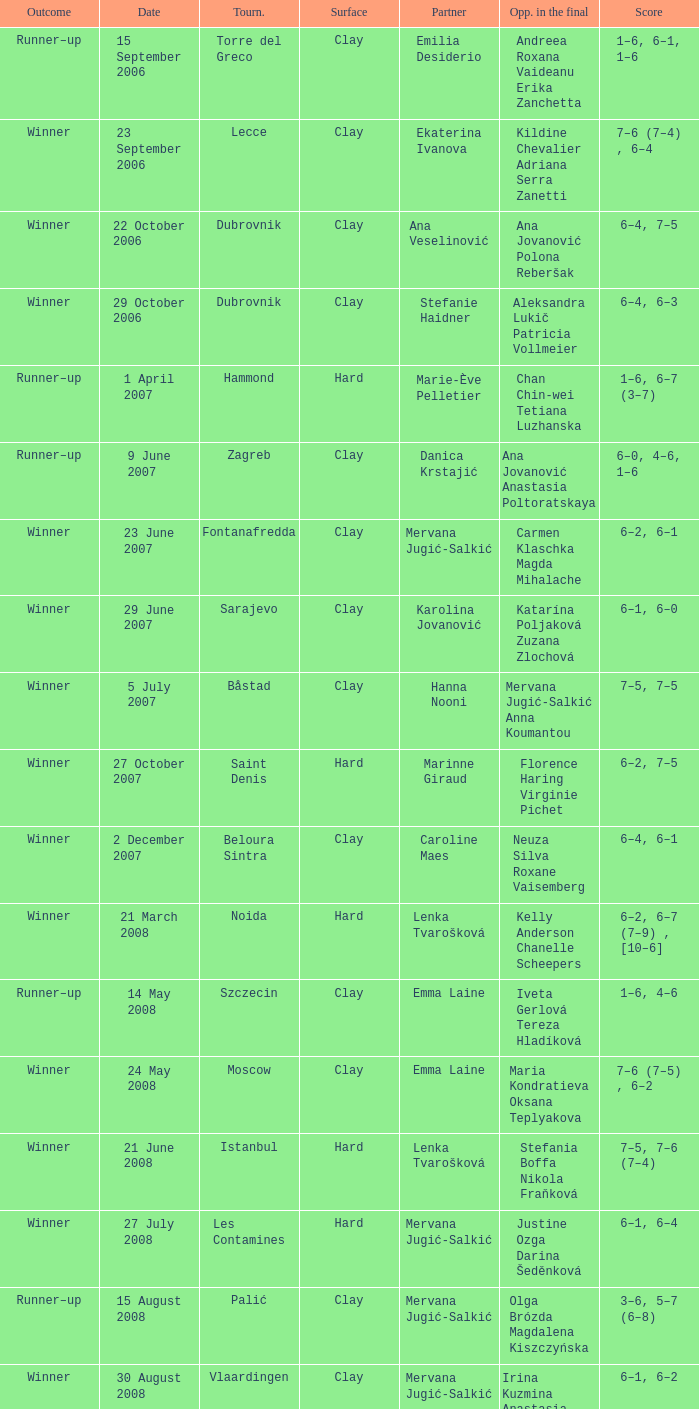Who were the opponents in the final at Noida? Kelly Anderson Chanelle Scheepers. Help me parse the entirety of this table. {'header': ['Outcome', 'Date', 'Tourn.', 'Surface', 'Partner', 'Opp. in the final', 'Score'], 'rows': [['Runner–up', '15 September 2006', 'Torre del Greco', 'Clay', 'Emilia Desiderio', 'Andreea Roxana Vaideanu Erika Zanchetta', '1–6, 6–1, 1–6'], ['Winner', '23 September 2006', 'Lecce', 'Clay', 'Ekaterina Ivanova', 'Kildine Chevalier Adriana Serra Zanetti', '7–6 (7–4) , 6–4'], ['Winner', '22 October 2006', 'Dubrovnik', 'Clay', 'Ana Veselinović', 'Ana Jovanović Polona Reberšak', '6–4, 7–5'], ['Winner', '29 October 2006', 'Dubrovnik', 'Clay', 'Stefanie Haidner', 'Aleksandra Lukič Patricia Vollmeier', '6–4, 6–3'], ['Runner–up', '1 April 2007', 'Hammond', 'Hard', 'Marie-Ève Pelletier', 'Chan Chin-wei Tetiana Luzhanska', '1–6, 6–7 (3–7)'], ['Runner–up', '9 June 2007', 'Zagreb', 'Clay', 'Danica Krstajić', 'Ana Jovanović Anastasia Poltoratskaya', '6–0, 4–6, 1–6'], ['Winner', '23 June 2007', 'Fontanafredda', 'Clay', 'Mervana Jugić-Salkić', 'Carmen Klaschka Magda Mihalache', '6–2, 6–1'], ['Winner', '29 June 2007', 'Sarajevo', 'Clay', 'Karolina Jovanović', 'Katarína Poljaková Zuzana Zlochová', '6–1, 6–0'], ['Winner', '5 July 2007', 'Båstad', 'Clay', 'Hanna Nooni', 'Mervana Jugić-Salkić Anna Koumantou', '7–5, 7–5'], ['Winner', '27 October 2007', 'Saint Denis', 'Hard', 'Marinne Giraud', 'Florence Haring Virginie Pichet', '6–2, 7–5'], ['Winner', '2 December 2007', 'Beloura Sintra', 'Clay', 'Caroline Maes', 'Neuza Silva Roxane Vaisemberg', '6–4, 6–1'], ['Winner', '21 March 2008', 'Noida', 'Hard', 'Lenka Tvarošková', 'Kelly Anderson Chanelle Scheepers', '6–2, 6–7 (7–9) , [10–6]'], ['Runner–up', '14 May 2008', 'Szczecin', 'Clay', 'Emma Laine', 'Iveta Gerlová Tereza Hladíková', '1–6, 4–6'], ['Winner', '24 May 2008', 'Moscow', 'Clay', 'Emma Laine', 'Maria Kondratieva Oksana Teplyakova', '7–6 (7–5) , 6–2'], ['Winner', '21 June 2008', 'Istanbul', 'Hard', 'Lenka Tvarošková', 'Stefania Boffa Nikola Fraňková', '7–5, 7–6 (7–4)'], ['Winner', '27 July 2008', 'Les Contamines', 'Hard', 'Mervana Jugić-Salkić', 'Justine Ozga Darina Šeděnková', '6–1, 6–4'], ['Runner–up', '15 August 2008', 'Palić', 'Clay', 'Mervana Jugić-Salkić', 'Olga Brózda Magdalena Kiszczyńska', '3–6, 5–7 (6–8)'], ['Winner', '30 August 2008', 'Vlaardingen', 'Clay', 'Mervana Jugić-Salkić', 'Irina Kuzmina Anastasia Poltoratskaya', '6–1, 6–2'], ['Winner', '22 November 2008', 'Phoenix', 'Hard', 'Lenka Tvarošková', 'Kelly Anderson Natalie Grandin', '6–4, 3–6, [10–4]'], ['Winner', '12 April 2009', 'Šibenik', 'Clay', 'Nataša Zorić', 'Tina Obrez Mika Urbančič', '6–0, 6–3'], ['Winner', '17 July 2009', 'Rome', 'Clay', 'María Irigoyen', 'Elisa Balsamo Stefania Chieppa', '7–5, 6–2'], ['Winner', '5 September 2009', 'Brčko', 'Clay', 'Ana Jovanović', 'Patricia Chirea Petra Pajalič', '6–4, 6–1'], ['Runner–up', '13 September 2009', 'Denain', 'Clay', 'Magdalena Kiszchzynska', 'Elena Chalova Ksenia Lykina', '4–6, 3–6'], ['Runner–up', '10 October 2009', 'Podgorica', 'Clay', 'Karolina Jovanović', 'Nicole Clerico Karolina Kosińska', '7–6 (7–4) , 4–6, [4–10]'], ['Runner–up', '25 April 2010', 'Dothan', 'Clay', 'María Irigoyen', 'Alina Jidkova Anastasia Yakimova', '4–6, 2–6'], ['Winner', '12 June 2010', 'Budapest', 'Clay', 'Lenka Wienerová', 'Anna Livadaru Florencia Molinero', '6–4, 6–1'], ['Winner', '2 July 2010', 'Toruń', 'Clay', 'Marija Mirkovic', 'Katarzyna Piter Barbara Sobaszkiewicz', '4–6, 6–2, [10–5]'], ['Winner', '10 July 2010', 'Aschaffenburg', 'Clay', 'Erika Sema', 'Elena Bogdan Andrea Koch Benvenuto', '7–6 (7–4) , 2–6, [10–8]'], ['Runner–up', '6 August 2010', 'Moscow', 'Clay', 'Marija Mirkovic', 'Nadejda Guskova Valeria Solovyeva', '6–7 (5–7) , 3–6'], ['Runner–up', '15 January 2011', 'Glasgow', 'Hard (i)', 'Jasmina Tinjić', 'Ulrikke Eikeri Isabella Shinikova', '4–6, 4–6'], ['Winner', '12 February 2011', 'Antalya', 'Clay', 'Maria Shamayko', 'Sultan Gönen Anna Karavayeva', '6–4, 6–4'], ['Runner–up', '29 April 2011', 'Minsk', 'Hard (i)', 'Nicole Rottmann', 'Lyudmyla Kichenok Nadiya Kichenok', '1–6, 2–6'], ['Winner', '18 June 2011', 'Istanbul', 'Hard', 'Marta Domachowska', 'Daniella Dominikovic Melis Sezer', '6–4, 6–2'], ['Winners', '10 September 2011', 'Saransk', 'Clay', 'Mihaela Buzărnescu', 'Eva Hrdinová Veronika Kapshay', '6–3, 6–1'], ['Runner–up', '19-Mar-2012', 'Antalya', 'Clay', 'Claudia Giovine', 'Evelyn Mayr (ITA) Julia Mayr', '2-6,3-6'], ['Winner', '23-Apr-2012', 'San Severo', 'Clay', 'Anastasia Grymalska', 'Chiara Mendo Giulia Sussarello', '6-2 6-4'], ['Winners', '26 May 2012', 'Timișoara , Romania', 'Clay', 'Andreea Mitu', 'Lina Gjorcheska Dalia Zafirova', '6–1, 6–2'], ['Runner–up', '04-Jun-2012', 'Karshi , UZBEKISTAN', 'Clay', 'Veronika Kapshay', 'Valentyna Ivakhnenko Kateryna Kozlova', '5-7,3-6'], ['Winners', '25-Jun-2012', 'Izmir , TURKEY', 'Hard', 'Ana Bogdan', 'Abbie Myers Melis Sezer', '6-3, 3-0 RET'], ['Runner–up', '25-Jun-2012', 'Mestre , ITA', 'Clay', 'Reka-Luca Jani', 'Mailen Auroux Maria Irigoyen', '7-5,4-6 8-10'], ['Runner–up', '04-Feb-2013', 'Antalya , TURKEY', 'Clay', 'Ana Bogdan', 'Giulia Bruzzone Martina Caregaro', '3-6,6-1 6-10'], ['Winners', '11-Feb-2013', 'Antalya , TURKEY', 'Clay', 'Raluca Elena Platon', 'Ekaterine Gorgodze Sofia Kvatsabaia', '1-6 4-5 RET'], ['Winners', '01-Apr-2013', 'Heraklion , GRE', 'Carpet', 'Vivien Juhaszova', 'Giulia Sussarello Sara Sussarello', '7-5 6-7 (7) 10-4'], ['Winners', '08-Apr-2013', 'Heraklion , GRE', 'Carpet', 'Marina Melnikova', 'Giulia Sussarello Despina Papamichail', '6-1 6-4'], ['Winner', '13 May 2013', 'Balikpapan , Indonesia', 'Hard', 'Naomi Broady', 'Chen Yi Xu Yifan', '6–3, 6–3'], ['Winner', '20 May 2013', 'Tarakan , Indonesia', 'Hard (i)', 'Naomi Broady', 'Tang Haochen Tian Ran', '6–2, 1–6, [10–5]'], ['Runner–up', '03-Jun-2013', 'Karshi , Uzbekıstan', 'Clay', 'Veronika Kapshay', 'Margarita Gasparyan Polina Pekhova', '2-6,1-6'], ['Winner', '16 September 2013', 'Dobrich , Bulgaria', 'Clay', 'Xenia Knoll', 'Isabella Shinikova Dalia Zafirova', '7-5, 7–6(7–5)']]} 